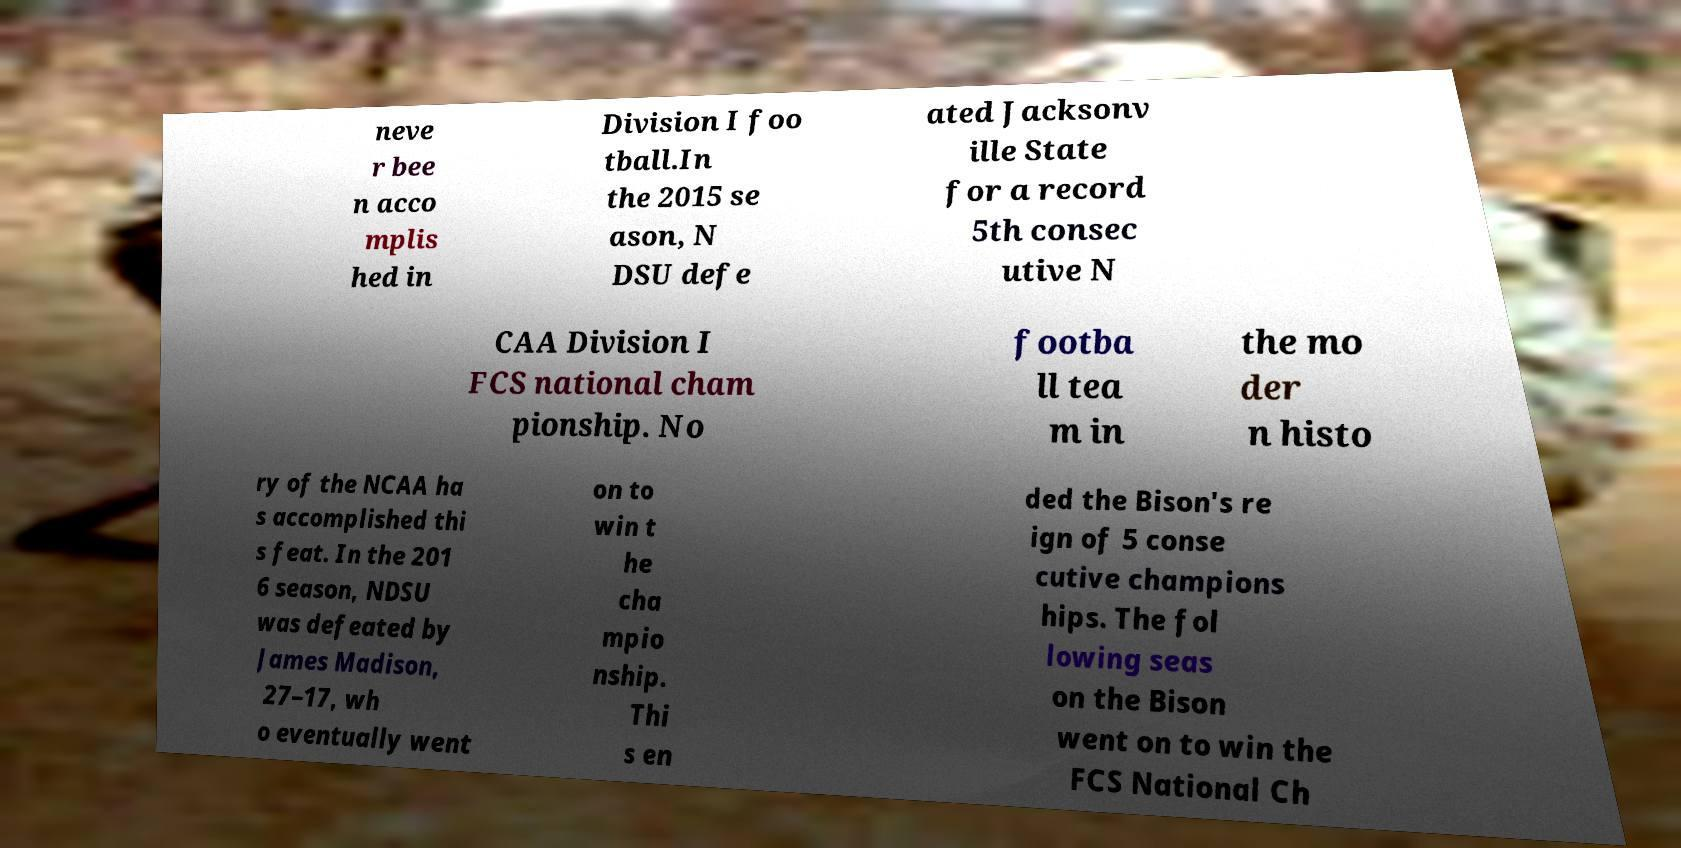There's text embedded in this image that I need extracted. Can you transcribe it verbatim? neve r bee n acco mplis hed in Division I foo tball.In the 2015 se ason, N DSU defe ated Jacksonv ille State for a record 5th consec utive N CAA Division I FCS national cham pionship. No footba ll tea m in the mo der n histo ry of the NCAA ha s accomplished thi s feat. In the 201 6 season, NDSU was defeated by James Madison, 27–17, wh o eventually went on to win t he cha mpio nship. Thi s en ded the Bison's re ign of 5 conse cutive champions hips. The fol lowing seas on the Bison went on to win the FCS National Ch 